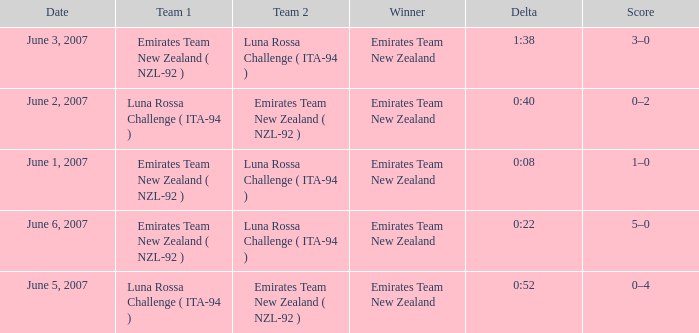Who is the Winner on June 2, 2007? Emirates Team New Zealand. 